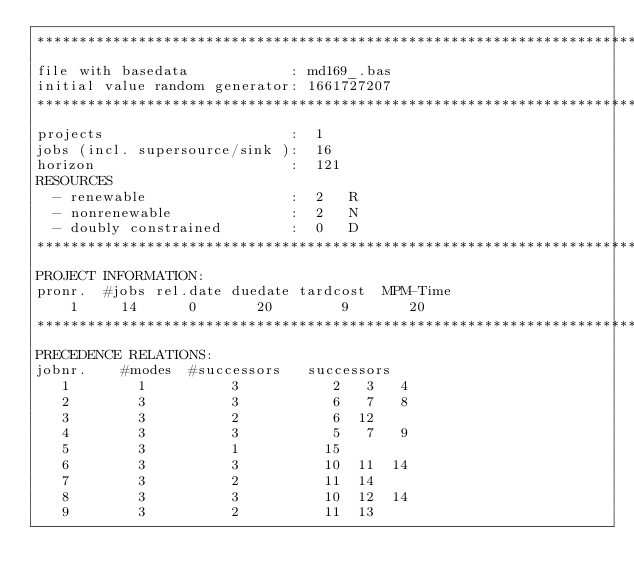<code> <loc_0><loc_0><loc_500><loc_500><_ObjectiveC_>************************************************************************
file with basedata            : md169_.bas
initial value random generator: 1661727207
************************************************************************
projects                      :  1
jobs (incl. supersource/sink ):  16
horizon                       :  121
RESOURCES
  - renewable                 :  2   R
  - nonrenewable              :  2   N
  - doubly constrained        :  0   D
************************************************************************
PROJECT INFORMATION:
pronr.  #jobs rel.date duedate tardcost  MPM-Time
    1     14      0       20        9       20
************************************************************************
PRECEDENCE RELATIONS:
jobnr.    #modes  #successors   successors
   1        1          3           2   3   4
   2        3          3           6   7   8
   3        3          2           6  12
   4        3          3           5   7   9
   5        3          1          15
   6        3          3          10  11  14
   7        3          2          11  14
   8        3          3          10  12  14
   9        3          2          11  13</code> 